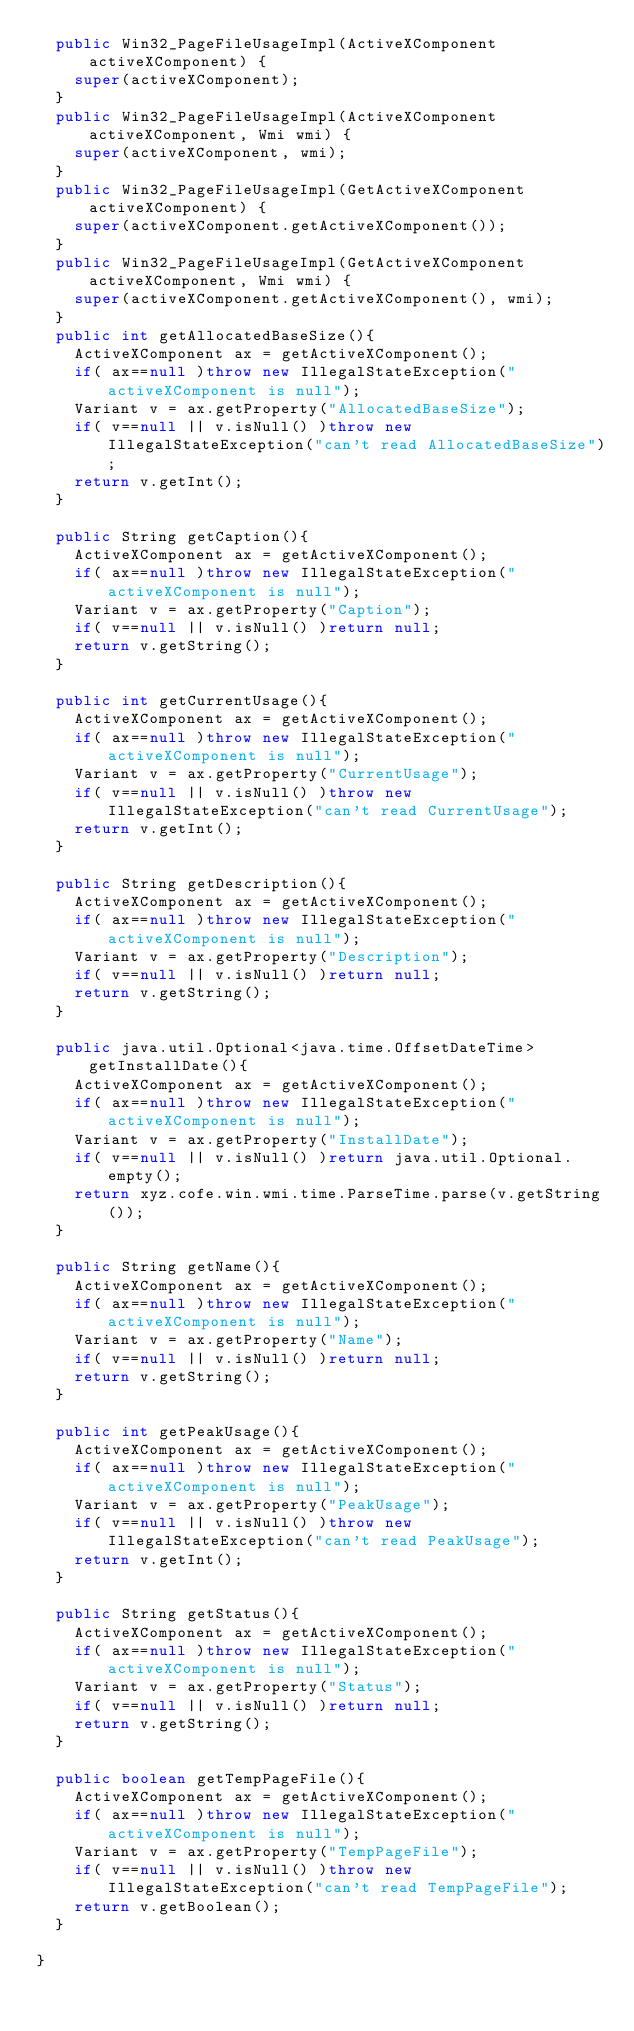Convert code to text. <code><loc_0><loc_0><loc_500><loc_500><_Java_>  public Win32_PageFileUsageImpl(ActiveXComponent activeXComponent) {
    super(activeXComponent);
  }
  public Win32_PageFileUsageImpl(ActiveXComponent activeXComponent, Wmi wmi) {
    super(activeXComponent, wmi);
  }
  public Win32_PageFileUsageImpl(GetActiveXComponent activeXComponent) {
    super(activeXComponent.getActiveXComponent());
  }
  public Win32_PageFileUsageImpl(GetActiveXComponent activeXComponent, Wmi wmi) {
    super(activeXComponent.getActiveXComponent(), wmi);
  }
  public int getAllocatedBaseSize(){
    ActiveXComponent ax = getActiveXComponent();
    if( ax==null )throw new IllegalStateException("activeXComponent is null");
    Variant v = ax.getProperty("AllocatedBaseSize");
    if( v==null || v.isNull() )throw new IllegalStateException("can't read AllocatedBaseSize");
    return v.getInt();
  }
  
  public String getCaption(){
    ActiveXComponent ax = getActiveXComponent();
    if( ax==null )throw new IllegalStateException("activeXComponent is null");
    Variant v = ax.getProperty("Caption");
    if( v==null || v.isNull() )return null;
    return v.getString();
  }
  
  public int getCurrentUsage(){
    ActiveXComponent ax = getActiveXComponent();
    if( ax==null )throw new IllegalStateException("activeXComponent is null");
    Variant v = ax.getProperty("CurrentUsage");
    if( v==null || v.isNull() )throw new IllegalStateException("can't read CurrentUsage");
    return v.getInt();
  }
  
  public String getDescription(){
    ActiveXComponent ax = getActiveXComponent();
    if( ax==null )throw new IllegalStateException("activeXComponent is null");
    Variant v = ax.getProperty("Description");
    if( v==null || v.isNull() )return null;
    return v.getString();
  }
  
  public java.util.Optional<java.time.OffsetDateTime> getInstallDate(){
    ActiveXComponent ax = getActiveXComponent();
    if( ax==null )throw new IllegalStateException("activeXComponent is null");
    Variant v = ax.getProperty("InstallDate");
    if( v==null || v.isNull() )return java.util.Optional.empty();
    return xyz.cofe.win.wmi.time.ParseTime.parse(v.getString());
  }
  
  public String getName(){
    ActiveXComponent ax = getActiveXComponent();
    if( ax==null )throw new IllegalStateException("activeXComponent is null");
    Variant v = ax.getProperty("Name");
    if( v==null || v.isNull() )return null;
    return v.getString();
  }
  
  public int getPeakUsage(){
    ActiveXComponent ax = getActiveXComponent();
    if( ax==null )throw new IllegalStateException("activeXComponent is null");
    Variant v = ax.getProperty("PeakUsage");
    if( v==null || v.isNull() )throw new IllegalStateException("can't read PeakUsage");
    return v.getInt();
  }
  
  public String getStatus(){
    ActiveXComponent ax = getActiveXComponent();
    if( ax==null )throw new IllegalStateException("activeXComponent is null");
    Variant v = ax.getProperty("Status");
    if( v==null || v.isNull() )return null;
    return v.getString();
  }
  
  public boolean getTempPageFile(){
    ActiveXComponent ax = getActiveXComponent();
    if( ax==null )throw new IllegalStateException("activeXComponent is null");
    Variant v = ax.getProperty("TempPageFile");
    if( v==null || v.isNull() )throw new IllegalStateException("can't read TempPageFile");
    return v.getBoolean();
  }
  
}
</code> 